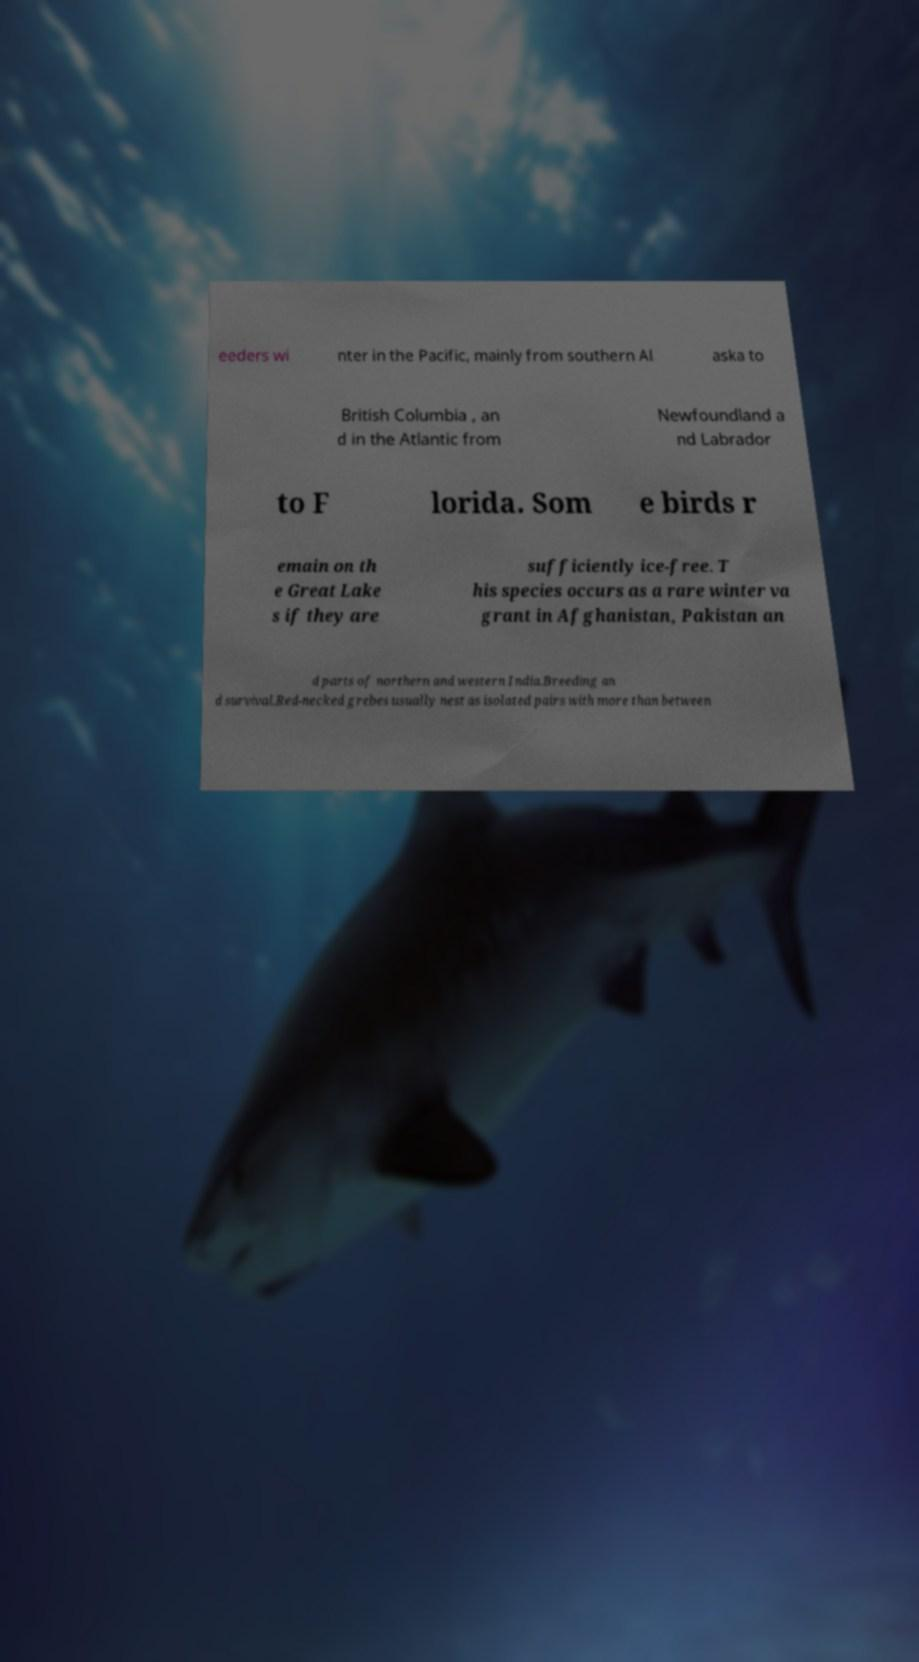Can you read and provide the text displayed in the image?This photo seems to have some interesting text. Can you extract and type it out for me? eeders wi nter in the Pacific, mainly from southern Al aska to British Columbia , an d in the Atlantic from Newfoundland a nd Labrador to F lorida. Som e birds r emain on th e Great Lake s if they are sufficiently ice-free. T his species occurs as a rare winter va grant in Afghanistan, Pakistan an d parts of northern and western India.Breeding an d survival.Red-necked grebes usually nest as isolated pairs with more than between 